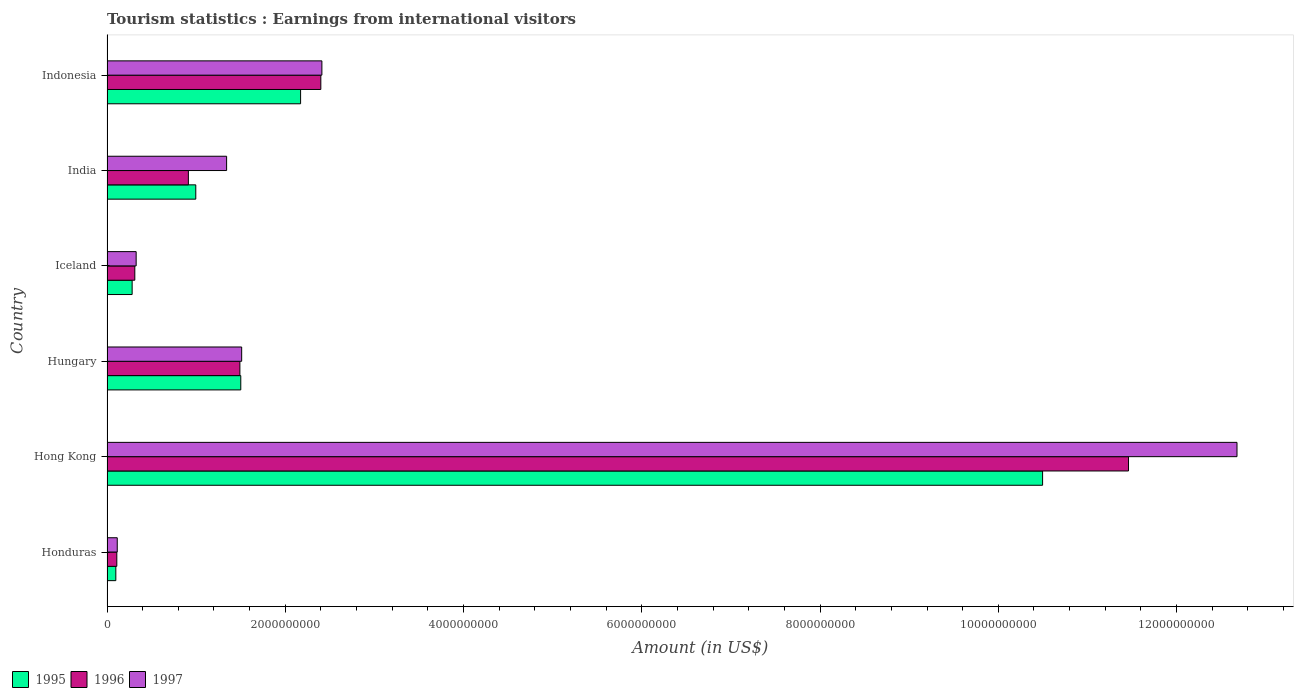How many groups of bars are there?
Make the answer very short. 6. Are the number of bars on each tick of the Y-axis equal?
Your answer should be very brief. Yes. What is the earnings from international visitors in 1996 in Hungary?
Keep it short and to the point. 1.49e+09. Across all countries, what is the maximum earnings from international visitors in 1995?
Your answer should be compact. 1.05e+1. Across all countries, what is the minimum earnings from international visitors in 1995?
Provide a succinct answer. 9.90e+07. In which country was the earnings from international visitors in 1996 maximum?
Make the answer very short. Hong Kong. In which country was the earnings from international visitors in 1996 minimum?
Ensure brevity in your answer.  Honduras. What is the total earnings from international visitors in 1995 in the graph?
Your answer should be compact. 1.55e+1. What is the difference between the earnings from international visitors in 1996 in Honduras and that in Hong Kong?
Ensure brevity in your answer.  -1.14e+1. What is the difference between the earnings from international visitors in 1995 in Hong Kong and the earnings from international visitors in 1997 in Iceland?
Your answer should be compact. 1.02e+1. What is the average earnings from international visitors in 1997 per country?
Offer a terse response. 3.06e+09. What is the difference between the earnings from international visitors in 1997 and earnings from international visitors in 1995 in Iceland?
Offer a very short reply. 4.50e+07. In how many countries, is the earnings from international visitors in 1995 greater than 11200000000 US$?
Your answer should be very brief. 0. What is the ratio of the earnings from international visitors in 1996 in Honduras to that in Hungary?
Your answer should be compact. 0.07. Is the earnings from international visitors in 1995 in Iceland less than that in India?
Your response must be concise. Yes. What is the difference between the highest and the second highest earnings from international visitors in 1996?
Your answer should be very brief. 9.06e+09. What is the difference between the highest and the lowest earnings from international visitors in 1995?
Give a very brief answer. 1.04e+1. What does the 2nd bar from the bottom in Indonesia represents?
Your answer should be very brief. 1996. How many bars are there?
Your answer should be very brief. 18. How many countries are there in the graph?
Your response must be concise. 6. What is the difference between two consecutive major ticks on the X-axis?
Keep it short and to the point. 2.00e+09. Are the values on the major ticks of X-axis written in scientific E-notation?
Provide a short and direct response. No. Does the graph contain grids?
Give a very brief answer. No. Where does the legend appear in the graph?
Provide a succinct answer. Bottom left. What is the title of the graph?
Keep it short and to the point. Tourism statistics : Earnings from international visitors. Does "2013" appear as one of the legend labels in the graph?
Offer a terse response. No. What is the label or title of the X-axis?
Offer a very short reply. Amount (in US$). What is the label or title of the Y-axis?
Offer a terse response. Country. What is the Amount (in US$) of 1995 in Honduras?
Your answer should be very brief. 9.90e+07. What is the Amount (in US$) of 1996 in Honduras?
Provide a succinct answer. 1.10e+08. What is the Amount (in US$) in 1997 in Honduras?
Your answer should be compact. 1.15e+08. What is the Amount (in US$) of 1995 in Hong Kong?
Make the answer very short. 1.05e+1. What is the Amount (in US$) in 1996 in Hong Kong?
Your answer should be compact. 1.15e+1. What is the Amount (in US$) of 1997 in Hong Kong?
Provide a succinct answer. 1.27e+1. What is the Amount (in US$) in 1995 in Hungary?
Ensure brevity in your answer.  1.50e+09. What is the Amount (in US$) in 1996 in Hungary?
Offer a very short reply. 1.49e+09. What is the Amount (in US$) of 1997 in Hungary?
Give a very brief answer. 1.51e+09. What is the Amount (in US$) in 1995 in Iceland?
Your answer should be very brief. 2.82e+08. What is the Amount (in US$) in 1996 in Iceland?
Offer a very short reply. 3.12e+08. What is the Amount (in US$) in 1997 in Iceland?
Keep it short and to the point. 3.27e+08. What is the Amount (in US$) of 1995 in India?
Your response must be concise. 9.96e+08. What is the Amount (in US$) of 1996 in India?
Offer a very short reply. 9.13e+08. What is the Amount (in US$) in 1997 in India?
Give a very brief answer. 1.34e+09. What is the Amount (in US$) in 1995 in Indonesia?
Your answer should be compact. 2.17e+09. What is the Amount (in US$) of 1996 in Indonesia?
Provide a succinct answer. 2.40e+09. What is the Amount (in US$) of 1997 in Indonesia?
Keep it short and to the point. 2.41e+09. Across all countries, what is the maximum Amount (in US$) of 1995?
Provide a short and direct response. 1.05e+1. Across all countries, what is the maximum Amount (in US$) in 1996?
Your answer should be very brief. 1.15e+1. Across all countries, what is the maximum Amount (in US$) in 1997?
Make the answer very short. 1.27e+1. Across all countries, what is the minimum Amount (in US$) of 1995?
Your answer should be compact. 9.90e+07. Across all countries, what is the minimum Amount (in US$) in 1996?
Keep it short and to the point. 1.10e+08. Across all countries, what is the minimum Amount (in US$) of 1997?
Ensure brevity in your answer.  1.15e+08. What is the total Amount (in US$) in 1995 in the graph?
Provide a short and direct response. 1.55e+1. What is the total Amount (in US$) in 1996 in the graph?
Give a very brief answer. 1.67e+1. What is the total Amount (in US$) of 1997 in the graph?
Offer a terse response. 1.84e+1. What is the difference between the Amount (in US$) of 1995 in Honduras and that in Hong Kong?
Offer a terse response. -1.04e+1. What is the difference between the Amount (in US$) in 1996 in Honduras and that in Hong Kong?
Your answer should be compact. -1.14e+1. What is the difference between the Amount (in US$) of 1997 in Honduras and that in Hong Kong?
Your answer should be compact. -1.26e+1. What is the difference between the Amount (in US$) of 1995 in Honduras and that in Hungary?
Ensure brevity in your answer.  -1.40e+09. What is the difference between the Amount (in US$) in 1996 in Honduras and that in Hungary?
Your answer should be very brief. -1.38e+09. What is the difference between the Amount (in US$) of 1997 in Honduras and that in Hungary?
Ensure brevity in your answer.  -1.40e+09. What is the difference between the Amount (in US$) of 1995 in Honduras and that in Iceland?
Your answer should be compact. -1.83e+08. What is the difference between the Amount (in US$) in 1996 in Honduras and that in Iceland?
Your answer should be compact. -2.02e+08. What is the difference between the Amount (in US$) of 1997 in Honduras and that in Iceland?
Ensure brevity in your answer.  -2.12e+08. What is the difference between the Amount (in US$) of 1995 in Honduras and that in India?
Keep it short and to the point. -8.97e+08. What is the difference between the Amount (in US$) in 1996 in Honduras and that in India?
Offer a very short reply. -8.03e+08. What is the difference between the Amount (in US$) of 1997 in Honduras and that in India?
Ensure brevity in your answer.  -1.23e+09. What is the difference between the Amount (in US$) of 1995 in Honduras and that in Indonesia?
Offer a very short reply. -2.07e+09. What is the difference between the Amount (in US$) in 1996 in Honduras and that in Indonesia?
Offer a very short reply. -2.29e+09. What is the difference between the Amount (in US$) in 1997 in Honduras and that in Indonesia?
Your response must be concise. -2.30e+09. What is the difference between the Amount (in US$) in 1995 in Hong Kong and that in Hungary?
Provide a short and direct response. 9.00e+09. What is the difference between the Amount (in US$) in 1996 in Hong Kong and that in Hungary?
Your answer should be compact. 9.97e+09. What is the difference between the Amount (in US$) in 1997 in Hong Kong and that in Hungary?
Your answer should be very brief. 1.12e+1. What is the difference between the Amount (in US$) in 1995 in Hong Kong and that in Iceland?
Your response must be concise. 1.02e+1. What is the difference between the Amount (in US$) in 1996 in Hong Kong and that in Iceland?
Offer a very short reply. 1.11e+1. What is the difference between the Amount (in US$) of 1997 in Hong Kong and that in Iceland?
Make the answer very short. 1.24e+1. What is the difference between the Amount (in US$) of 1995 in Hong Kong and that in India?
Keep it short and to the point. 9.50e+09. What is the difference between the Amount (in US$) in 1996 in Hong Kong and that in India?
Your answer should be very brief. 1.05e+1. What is the difference between the Amount (in US$) in 1997 in Hong Kong and that in India?
Provide a succinct answer. 1.13e+1. What is the difference between the Amount (in US$) of 1995 in Hong Kong and that in Indonesia?
Your answer should be compact. 8.32e+09. What is the difference between the Amount (in US$) in 1996 in Hong Kong and that in Indonesia?
Your response must be concise. 9.06e+09. What is the difference between the Amount (in US$) in 1997 in Hong Kong and that in Indonesia?
Your answer should be compact. 1.03e+1. What is the difference between the Amount (in US$) in 1995 in Hungary and that in Iceland?
Your response must be concise. 1.22e+09. What is the difference between the Amount (in US$) of 1996 in Hungary and that in Iceland?
Your response must be concise. 1.18e+09. What is the difference between the Amount (in US$) of 1997 in Hungary and that in Iceland?
Your answer should be very brief. 1.18e+09. What is the difference between the Amount (in US$) of 1995 in Hungary and that in India?
Provide a succinct answer. 5.05e+08. What is the difference between the Amount (in US$) in 1996 in Hungary and that in India?
Make the answer very short. 5.78e+08. What is the difference between the Amount (in US$) of 1997 in Hungary and that in India?
Keep it short and to the point. 1.69e+08. What is the difference between the Amount (in US$) of 1995 in Hungary and that in Indonesia?
Provide a succinct answer. -6.71e+08. What is the difference between the Amount (in US$) in 1996 in Hungary and that in Indonesia?
Your answer should be compact. -9.08e+08. What is the difference between the Amount (in US$) of 1997 in Hungary and that in Indonesia?
Your response must be concise. -9.00e+08. What is the difference between the Amount (in US$) in 1995 in Iceland and that in India?
Offer a terse response. -7.14e+08. What is the difference between the Amount (in US$) in 1996 in Iceland and that in India?
Ensure brevity in your answer.  -6.01e+08. What is the difference between the Amount (in US$) of 1997 in Iceland and that in India?
Your answer should be compact. -1.02e+09. What is the difference between the Amount (in US$) in 1995 in Iceland and that in Indonesia?
Keep it short and to the point. -1.89e+09. What is the difference between the Amount (in US$) in 1996 in Iceland and that in Indonesia?
Your answer should be compact. -2.09e+09. What is the difference between the Amount (in US$) in 1997 in Iceland and that in Indonesia?
Provide a short and direct response. -2.08e+09. What is the difference between the Amount (in US$) of 1995 in India and that in Indonesia?
Make the answer very short. -1.18e+09. What is the difference between the Amount (in US$) of 1996 in India and that in Indonesia?
Offer a very short reply. -1.49e+09. What is the difference between the Amount (in US$) of 1997 in India and that in Indonesia?
Offer a very short reply. -1.07e+09. What is the difference between the Amount (in US$) of 1995 in Honduras and the Amount (in US$) of 1996 in Hong Kong?
Make the answer very short. -1.14e+1. What is the difference between the Amount (in US$) in 1995 in Honduras and the Amount (in US$) in 1997 in Hong Kong?
Offer a terse response. -1.26e+1. What is the difference between the Amount (in US$) of 1996 in Honduras and the Amount (in US$) of 1997 in Hong Kong?
Your answer should be compact. -1.26e+1. What is the difference between the Amount (in US$) in 1995 in Honduras and the Amount (in US$) in 1996 in Hungary?
Give a very brief answer. -1.39e+09. What is the difference between the Amount (in US$) in 1995 in Honduras and the Amount (in US$) in 1997 in Hungary?
Your answer should be very brief. -1.41e+09. What is the difference between the Amount (in US$) in 1996 in Honduras and the Amount (in US$) in 1997 in Hungary?
Make the answer very short. -1.40e+09. What is the difference between the Amount (in US$) in 1995 in Honduras and the Amount (in US$) in 1996 in Iceland?
Your response must be concise. -2.13e+08. What is the difference between the Amount (in US$) in 1995 in Honduras and the Amount (in US$) in 1997 in Iceland?
Your answer should be very brief. -2.28e+08. What is the difference between the Amount (in US$) in 1996 in Honduras and the Amount (in US$) in 1997 in Iceland?
Your answer should be very brief. -2.17e+08. What is the difference between the Amount (in US$) of 1995 in Honduras and the Amount (in US$) of 1996 in India?
Offer a very short reply. -8.14e+08. What is the difference between the Amount (in US$) in 1995 in Honduras and the Amount (in US$) in 1997 in India?
Offer a terse response. -1.24e+09. What is the difference between the Amount (in US$) of 1996 in Honduras and the Amount (in US$) of 1997 in India?
Make the answer very short. -1.23e+09. What is the difference between the Amount (in US$) in 1995 in Honduras and the Amount (in US$) in 1996 in Indonesia?
Keep it short and to the point. -2.30e+09. What is the difference between the Amount (in US$) in 1995 in Honduras and the Amount (in US$) in 1997 in Indonesia?
Give a very brief answer. -2.31e+09. What is the difference between the Amount (in US$) of 1996 in Honduras and the Amount (in US$) of 1997 in Indonesia?
Your response must be concise. -2.30e+09. What is the difference between the Amount (in US$) in 1995 in Hong Kong and the Amount (in US$) in 1996 in Hungary?
Your answer should be compact. 9.01e+09. What is the difference between the Amount (in US$) of 1995 in Hong Kong and the Amount (in US$) of 1997 in Hungary?
Offer a very short reply. 8.99e+09. What is the difference between the Amount (in US$) of 1996 in Hong Kong and the Amount (in US$) of 1997 in Hungary?
Your response must be concise. 9.95e+09. What is the difference between the Amount (in US$) in 1995 in Hong Kong and the Amount (in US$) in 1996 in Iceland?
Provide a short and direct response. 1.02e+1. What is the difference between the Amount (in US$) of 1995 in Hong Kong and the Amount (in US$) of 1997 in Iceland?
Provide a short and direct response. 1.02e+1. What is the difference between the Amount (in US$) in 1996 in Hong Kong and the Amount (in US$) in 1997 in Iceland?
Your answer should be compact. 1.11e+1. What is the difference between the Amount (in US$) of 1995 in Hong Kong and the Amount (in US$) of 1996 in India?
Provide a succinct answer. 9.58e+09. What is the difference between the Amount (in US$) in 1995 in Hong Kong and the Amount (in US$) in 1997 in India?
Provide a succinct answer. 9.16e+09. What is the difference between the Amount (in US$) in 1996 in Hong Kong and the Amount (in US$) in 1997 in India?
Your response must be concise. 1.01e+1. What is the difference between the Amount (in US$) in 1995 in Hong Kong and the Amount (in US$) in 1996 in Indonesia?
Ensure brevity in your answer.  8.10e+09. What is the difference between the Amount (in US$) of 1995 in Hong Kong and the Amount (in US$) of 1997 in Indonesia?
Your response must be concise. 8.09e+09. What is the difference between the Amount (in US$) of 1996 in Hong Kong and the Amount (in US$) of 1997 in Indonesia?
Your response must be concise. 9.05e+09. What is the difference between the Amount (in US$) of 1995 in Hungary and the Amount (in US$) of 1996 in Iceland?
Your answer should be very brief. 1.19e+09. What is the difference between the Amount (in US$) in 1995 in Hungary and the Amount (in US$) in 1997 in Iceland?
Provide a short and direct response. 1.17e+09. What is the difference between the Amount (in US$) in 1996 in Hungary and the Amount (in US$) in 1997 in Iceland?
Provide a short and direct response. 1.16e+09. What is the difference between the Amount (in US$) in 1995 in Hungary and the Amount (in US$) in 1996 in India?
Your answer should be very brief. 5.88e+08. What is the difference between the Amount (in US$) in 1995 in Hungary and the Amount (in US$) in 1997 in India?
Provide a succinct answer. 1.59e+08. What is the difference between the Amount (in US$) in 1996 in Hungary and the Amount (in US$) in 1997 in India?
Your response must be concise. 1.49e+08. What is the difference between the Amount (in US$) in 1995 in Hungary and the Amount (in US$) in 1996 in Indonesia?
Provide a succinct answer. -8.98e+08. What is the difference between the Amount (in US$) of 1995 in Hungary and the Amount (in US$) of 1997 in Indonesia?
Offer a very short reply. -9.10e+08. What is the difference between the Amount (in US$) of 1996 in Hungary and the Amount (in US$) of 1997 in Indonesia?
Provide a short and direct response. -9.20e+08. What is the difference between the Amount (in US$) in 1995 in Iceland and the Amount (in US$) in 1996 in India?
Your answer should be compact. -6.31e+08. What is the difference between the Amount (in US$) of 1995 in Iceland and the Amount (in US$) of 1997 in India?
Your answer should be very brief. -1.06e+09. What is the difference between the Amount (in US$) in 1996 in Iceland and the Amount (in US$) in 1997 in India?
Offer a very short reply. -1.03e+09. What is the difference between the Amount (in US$) in 1995 in Iceland and the Amount (in US$) in 1996 in Indonesia?
Your answer should be compact. -2.12e+09. What is the difference between the Amount (in US$) of 1995 in Iceland and the Amount (in US$) of 1997 in Indonesia?
Your response must be concise. -2.13e+09. What is the difference between the Amount (in US$) of 1996 in Iceland and the Amount (in US$) of 1997 in Indonesia?
Provide a short and direct response. -2.10e+09. What is the difference between the Amount (in US$) in 1995 in India and the Amount (in US$) in 1996 in Indonesia?
Provide a succinct answer. -1.40e+09. What is the difference between the Amount (in US$) of 1995 in India and the Amount (in US$) of 1997 in Indonesia?
Provide a short and direct response. -1.42e+09. What is the difference between the Amount (in US$) of 1996 in India and the Amount (in US$) of 1997 in Indonesia?
Offer a very short reply. -1.50e+09. What is the average Amount (in US$) in 1995 per country?
Your answer should be compact. 2.59e+09. What is the average Amount (in US$) of 1996 per country?
Give a very brief answer. 2.78e+09. What is the average Amount (in US$) in 1997 per country?
Ensure brevity in your answer.  3.06e+09. What is the difference between the Amount (in US$) of 1995 and Amount (in US$) of 1996 in Honduras?
Give a very brief answer. -1.10e+07. What is the difference between the Amount (in US$) in 1995 and Amount (in US$) in 1997 in Honduras?
Offer a terse response. -1.60e+07. What is the difference between the Amount (in US$) in 1996 and Amount (in US$) in 1997 in Honduras?
Your response must be concise. -5.00e+06. What is the difference between the Amount (in US$) of 1995 and Amount (in US$) of 1996 in Hong Kong?
Offer a very short reply. -9.64e+08. What is the difference between the Amount (in US$) in 1995 and Amount (in US$) in 1997 in Hong Kong?
Offer a very short reply. -2.18e+09. What is the difference between the Amount (in US$) in 1996 and Amount (in US$) in 1997 in Hong Kong?
Provide a succinct answer. -1.22e+09. What is the difference between the Amount (in US$) of 1995 and Amount (in US$) of 1996 in Hungary?
Provide a short and direct response. 1.00e+07. What is the difference between the Amount (in US$) in 1995 and Amount (in US$) in 1997 in Hungary?
Provide a short and direct response. -1.00e+07. What is the difference between the Amount (in US$) in 1996 and Amount (in US$) in 1997 in Hungary?
Ensure brevity in your answer.  -2.00e+07. What is the difference between the Amount (in US$) in 1995 and Amount (in US$) in 1996 in Iceland?
Your answer should be compact. -3.00e+07. What is the difference between the Amount (in US$) in 1995 and Amount (in US$) in 1997 in Iceland?
Your answer should be very brief. -4.50e+07. What is the difference between the Amount (in US$) in 1996 and Amount (in US$) in 1997 in Iceland?
Offer a very short reply. -1.50e+07. What is the difference between the Amount (in US$) of 1995 and Amount (in US$) of 1996 in India?
Your answer should be very brief. 8.30e+07. What is the difference between the Amount (in US$) in 1995 and Amount (in US$) in 1997 in India?
Ensure brevity in your answer.  -3.46e+08. What is the difference between the Amount (in US$) in 1996 and Amount (in US$) in 1997 in India?
Offer a terse response. -4.29e+08. What is the difference between the Amount (in US$) in 1995 and Amount (in US$) in 1996 in Indonesia?
Ensure brevity in your answer.  -2.27e+08. What is the difference between the Amount (in US$) of 1995 and Amount (in US$) of 1997 in Indonesia?
Give a very brief answer. -2.39e+08. What is the difference between the Amount (in US$) in 1996 and Amount (in US$) in 1997 in Indonesia?
Keep it short and to the point. -1.20e+07. What is the ratio of the Amount (in US$) in 1995 in Honduras to that in Hong Kong?
Your answer should be compact. 0.01. What is the ratio of the Amount (in US$) in 1996 in Honduras to that in Hong Kong?
Keep it short and to the point. 0.01. What is the ratio of the Amount (in US$) of 1997 in Honduras to that in Hong Kong?
Ensure brevity in your answer.  0.01. What is the ratio of the Amount (in US$) of 1995 in Honduras to that in Hungary?
Your answer should be very brief. 0.07. What is the ratio of the Amount (in US$) in 1996 in Honduras to that in Hungary?
Give a very brief answer. 0.07. What is the ratio of the Amount (in US$) in 1997 in Honduras to that in Hungary?
Your answer should be compact. 0.08. What is the ratio of the Amount (in US$) in 1995 in Honduras to that in Iceland?
Offer a terse response. 0.35. What is the ratio of the Amount (in US$) of 1996 in Honduras to that in Iceland?
Offer a very short reply. 0.35. What is the ratio of the Amount (in US$) of 1997 in Honduras to that in Iceland?
Provide a short and direct response. 0.35. What is the ratio of the Amount (in US$) in 1995 in Honduras to that in India?
Provide a succinct answer. 0.1. What is the ratio of the Amount (in US$) in 1996 in Honduras to that in India?
Provide a short and direct response. 0.12. What is the ratio of the Amount (in US$) in 1997 in Honduras to that in India?
Your answer should be very brief. 0.09. What is the ratio of the Amount (in US$) in 1995 in Honduras to that in Indonesia?
Offer a very short reply. 0.05. What is the ratio of the Amount (in US$) in 1996 in Honduras to that in Indonesia?
Your response must be concise. 0.05. What is the ratio of the Amount (in US$) in 1997 in Honduras to that in Indonesia?
Offer a very short reply. 0.05. What is the ratio of the Amount (in US$) of 1995 in Hong Kong to that in Hungary?
Offer a very short reply. 6.99. What is the ratio of the Amount (in US$) of 1996 in Hong Kong to that in Hungary?
Your response must be concise. 7.69. What is the ratio of the Amount (in US$) of 1997 in Hong Kong to that in Hungary?
Keep it short and to the point. 8.39. What is the ratio of the Amount (in US$) of 1995 in Hong Kong to that in Iceland?
Offer a terse response. 37.22. What is the ratio of the Amount (in US$) of 1996 in Hong Kong to that in Iceland?
Ensure brevity in your answer.  36.73. What is the ratio of the Amount (in US$) in 1997 in Hong Kong to that in Iceland?
Give a very brief answer. 38.77. What is the ratio of the Amount (in US$) of 1995 in Hong Kong to that in India?
Your answer should be very brief. 10.54. What is the ratio of the Amount (in US$) of 1996 in Hong Kong to that in India?
Provide a succinct answer. 12.55. What is the ratio of the Amount (in US$) in 1997 in Hong Kong to that in India?
Make the answer very short. 9.45. What is the ratio of the Amount (in US$) in 1995 in Hong Kong to that in Indonesia?
Offer a terse response. 4.83. What is the ratio of the Amount (in US$) of 1996 in Hong Kong to that in Indonesia?
Offer a terse response. 4.78. What is the ratio of the Amount (in US$) in 1997 in Hong Kong to that in Indonesia?
Your response must be concise. 5.26. What is the ratio of the Amount (in US$) of 1995 in Hungary to that in Iceland?
Make the answer very short. 5.32. What is the ratio of the Amount (in US$) of 1996 in Hungary to that in Iceland?
Offer a terse response. 4.78. What is the ratio of the Amount (in US$) of 1997 in Hungary to that in Iceland?
Keep it short and to the point. 4.62. What is the ratio of the Amount (in US$) in 1995 in Hungary to that in India?
Offer a very short reply. 1.51. What is the ratio of the Amount (in US$) in 1996 in Hungary to that in India?
Provide a succinct answer. 1.63. What is the ratio of the Amount (in US$) in 1997 in Hungary to that in India?
Provide a succinct answer. 1.13. What is the ratio of the Amount (in US$) in 1995 in Hungary to that in Indonesia?
Ensure brevity in your answer.  0.69. What is the ratio of the Amount (in US$) of 1996 in Hungary to that in Indonesia?
Provide a short and direct response. 0.62. What is the ratio of the Amount (in US$) in 1997 in Hungary to that in Indonesia?
Give a very brief answer. 0.63. What is the ratio of the Amount (in US$) of 1995 in Iceland to that in India?
Ensure brevity in your answer.  0.28. What is the ratio of the Amount (in US$) in 1996 in Iceland to that in India?
Make the answer very short. 0.34. What is the ratio of the Amount (in US$) in 1997 in Iceland to that in India?
Your answer should be compact. 0.24. What is the ratio of the Amount (in US$) of 1995 in Iceland to that in Indonesia?
Offer a terse response. 0.13. What is the ratio of the Amount (in US$) of 1996 in Iceland to that in Indonesia?
Offer a very short reply. 0.13. What is the ratio of the Amount (in US$) in 1997 in Iceland to that in Indonesia?
Your answer should be very brief. 0.14. What is the ratio of the Amount (in US$) in 1995 in India to that in Indonesia?
Your answer should be compact. 0.46. What is the ratio of the Amount (in US$) of 1996 in India to that in Indonesia?
Offer a very short reply. 0.38. What is the ratio of the Amount (in US$) of 1997 in India to that in Indonesia?
Offer a terse response. 0.56. What is the difference between the highest and the second highest Amount (in US$) in 1995?
Make the answer very short. 8.32e+09. What is the difference between the highest and the second highest Amount (in US$) in 1996?
Make the answer very short. 9.06e+09. What is the difference between the highest and the second highest Amount (in US$) in 1997?
Your answer should be compact. 1.03e+1. What is the difference between the highest and the lowest Amount (in US$) of 1995?
Provide a short and direct response. 1.04e+1. What is the difference between the highest and the lowest Amount (in US$) in 1996?
Offer a very short reply. 1.14e+1. What is the difference between the highest and the lowest Amount (in US$) of 1997?
Your answer should be very brief. 1.26e+1. 